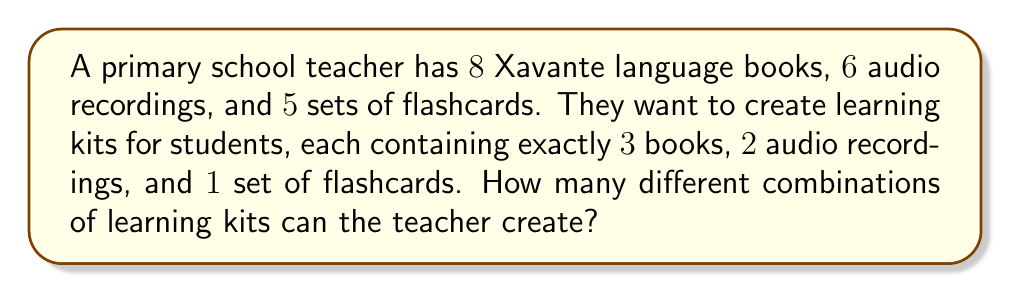Provide a solution to this math problem. Let's break this down step-by-step:

1) For the books:
   We need to choose 3 books out of 8. This is a combination problem.
   Number of ways to choose books = $\binom{8}{3}$

2) For the audio recordings:
   We need to choose 2 recordings out of 6.
   Number of ways to choose recordings = $\binom{6}{2}$

3) For the flashcards:
   We need to choose 1 set out of 5.
   Number of ways to choose flashcards = $\binom{5}{1}$

4) To calculate each combination:

   $\binom{8}{3} = \frac{8!}{3!(8-3)!} = \frac{8!}{3!5!} = 56$

   $\binom{6}{2} = \frac{6!}{2!(6-2)!} = \frac{6!}{2!4!} = 15$

   $\binom{5}{1} = \frac{5!}{1!(5-1)!} = \frac{5!}{1!4!} = 5$

5) By the multiplication principle, the total number of different combinations is:

   $56 \times 15 \times 5 = 4,200$

Therefore, the teacher can create 4,200 different combinations of learning kits.
Answer: 4,200 